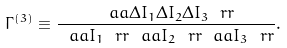<formula> <loc_0><loc_0><loc_500><loc_500>\Gamma ^ { ( 3 ) } \equiv \frac { \ a a \Delta I _ { 1 } \Delta I _ { 2 } \Delta I _ { 3 } \ r r } { \ a a I _ { 1 } \ r r \ a a I _ { 2 } \ r r \ a a I _ { 3 } \ r r } .</formula> 